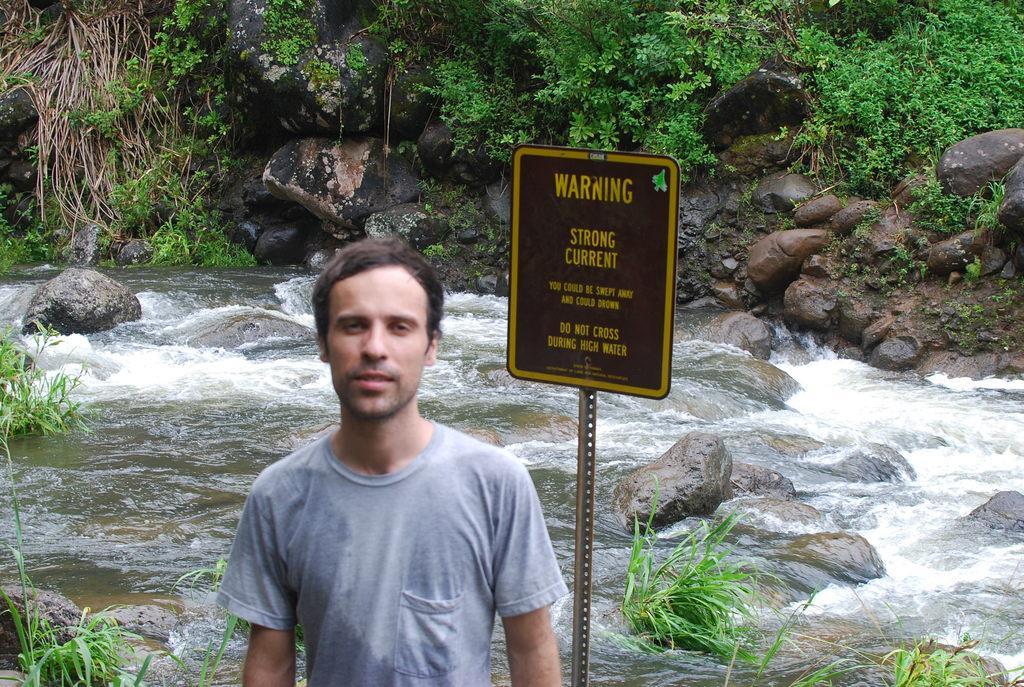Please provide a concise description of this image. In this image, we can see a man and in the background, there is a board, rocks and plants. At the bottom, there is water. 